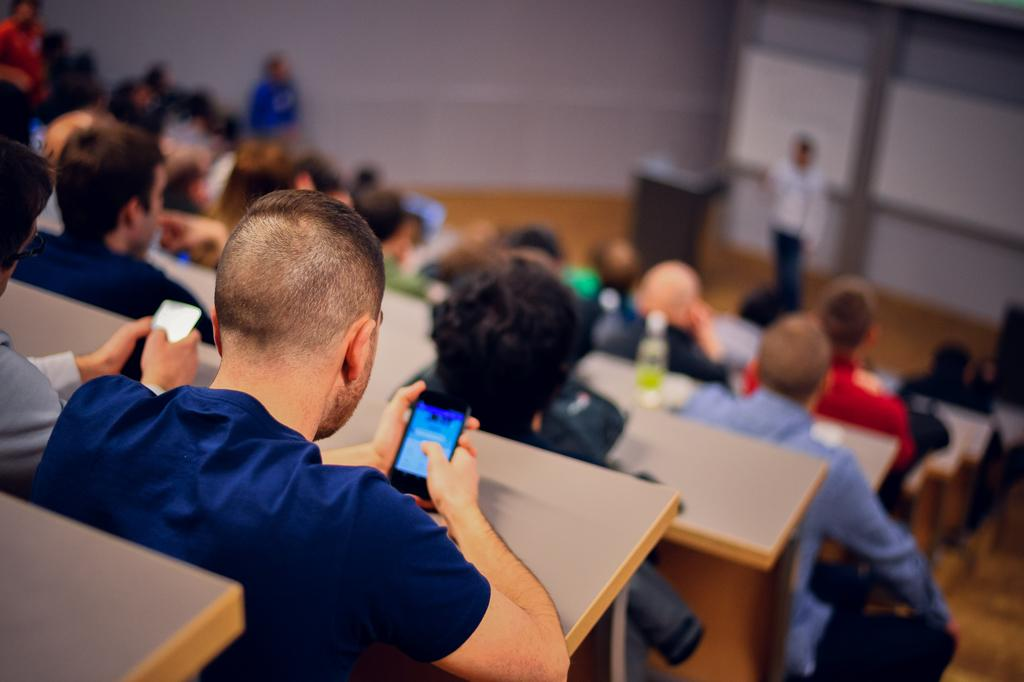What are the people in the image doing? The people in the image are sitting on benches. Can you describe the person near the podium? There is a person standing near a podium in the image. What type of wilderness can be seen in the background of the image? There is no wilderness visible in the image; it primarily features people sitting on benches and a person standing near a podium. 